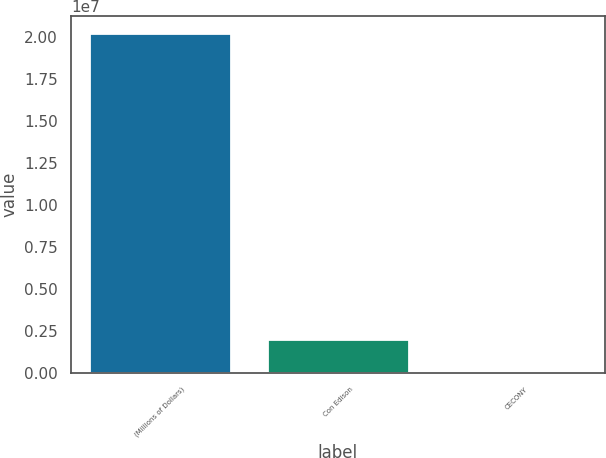Convert chart to OTSL. <chart><loc_0><loc_0><loc_500><loc_500><bar_chart><fcel>(Millions of Dollars)<fcel>Con Edison<fcel>CECONY<nl><fcel>2.0222e+07<fcel>2.02555e+06<fcel>3716<nl></chart> 